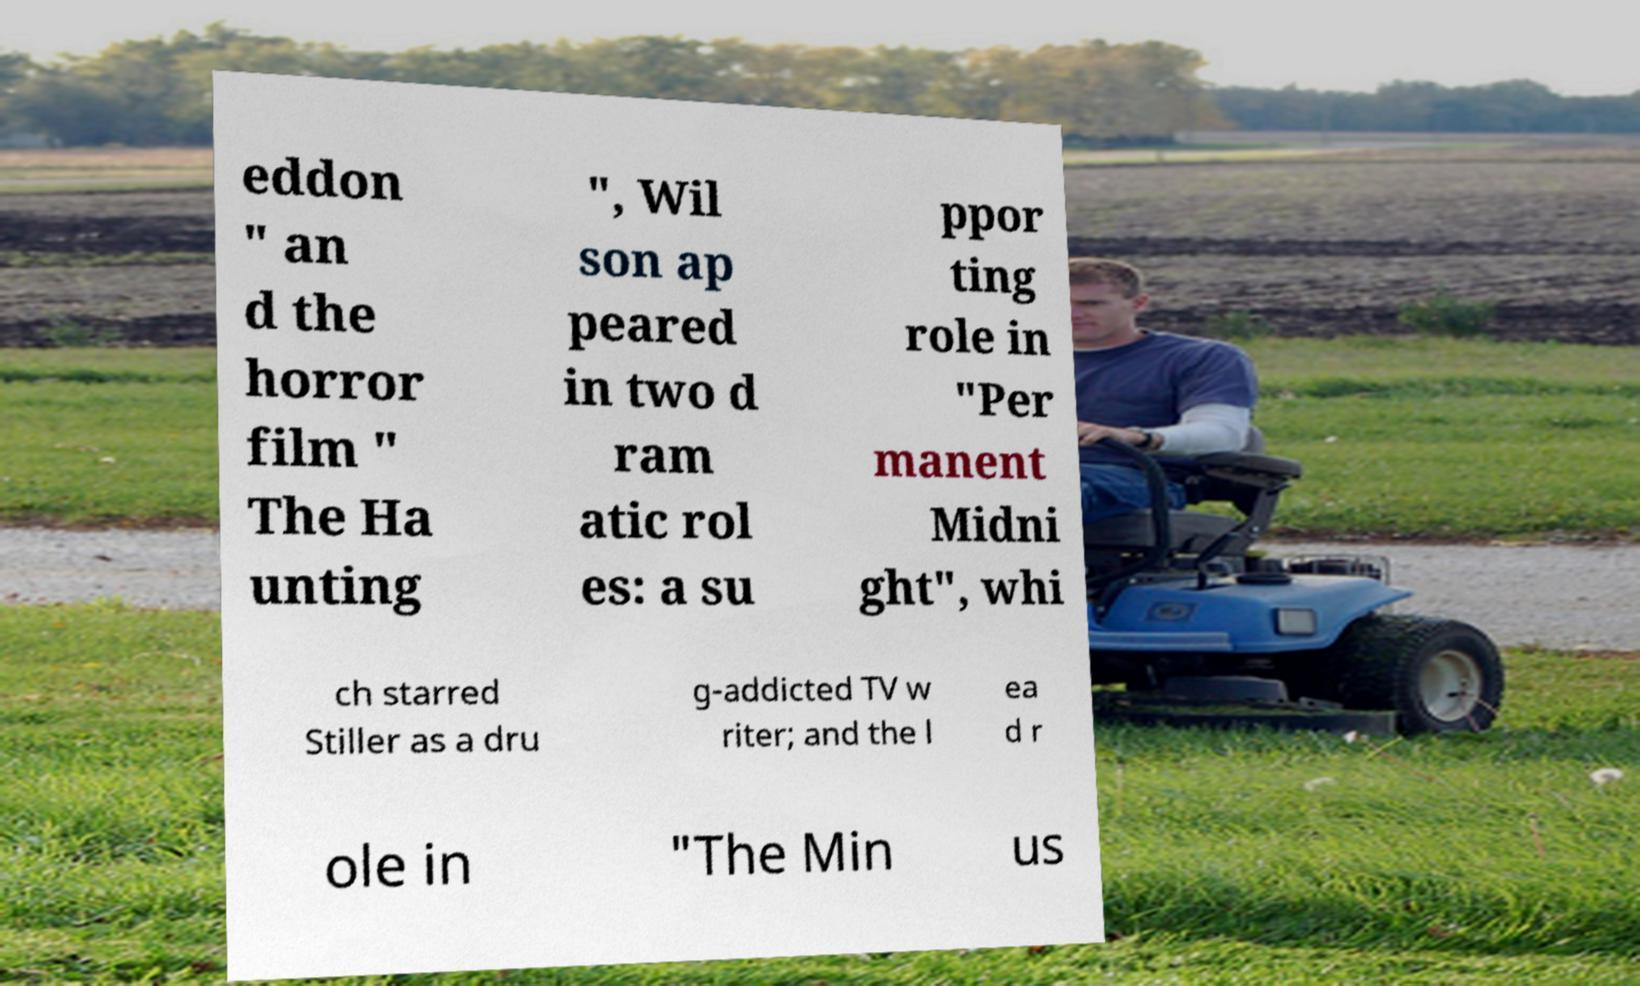Please identify and transcribe the text found in this image. eddon " an d the horror film " The Ha unting ", Wil son ap peared in two d ram atic rol es: a su ppor ting role in "Per manent Midni ght", whi ch starred Stiller as a dru g-addicted TV w riter; and the l ea d r ole in "The Min us 